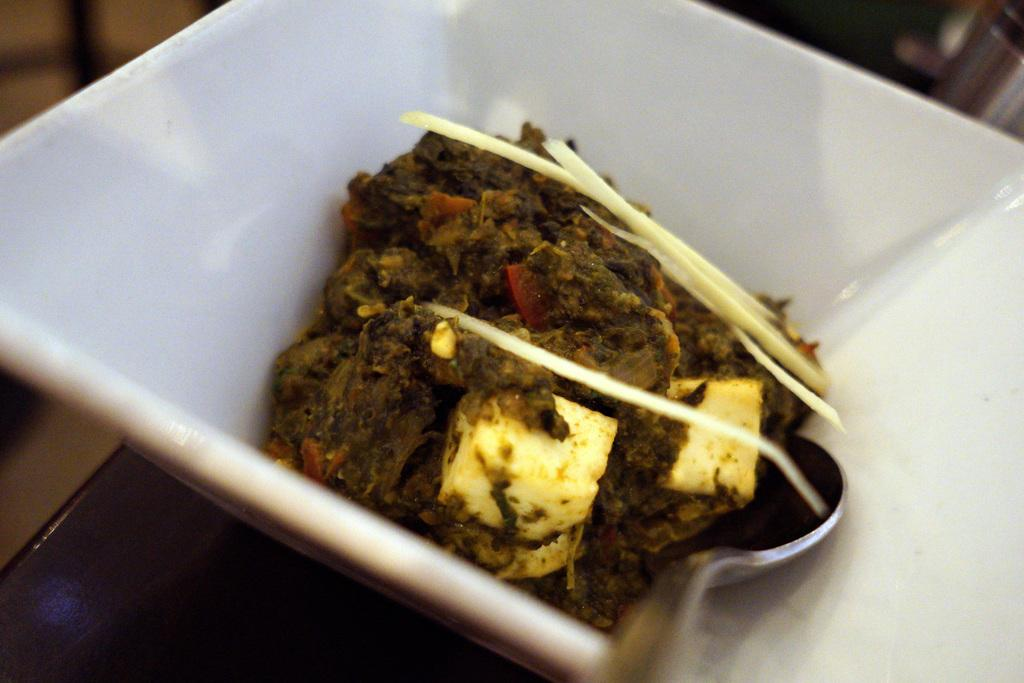What type of cooked food item can be seen in the image? There is a cooked food item in the image, but the specific type is not mentioned. How is the food item served? The food item is served in a cup. What utensil is provided with the food item? There is a spoon beside the food in the image. How many trees are visible in the image? There are no trees visible in the image; it only features a cooked food item served in a cup with a spoon beside it. 